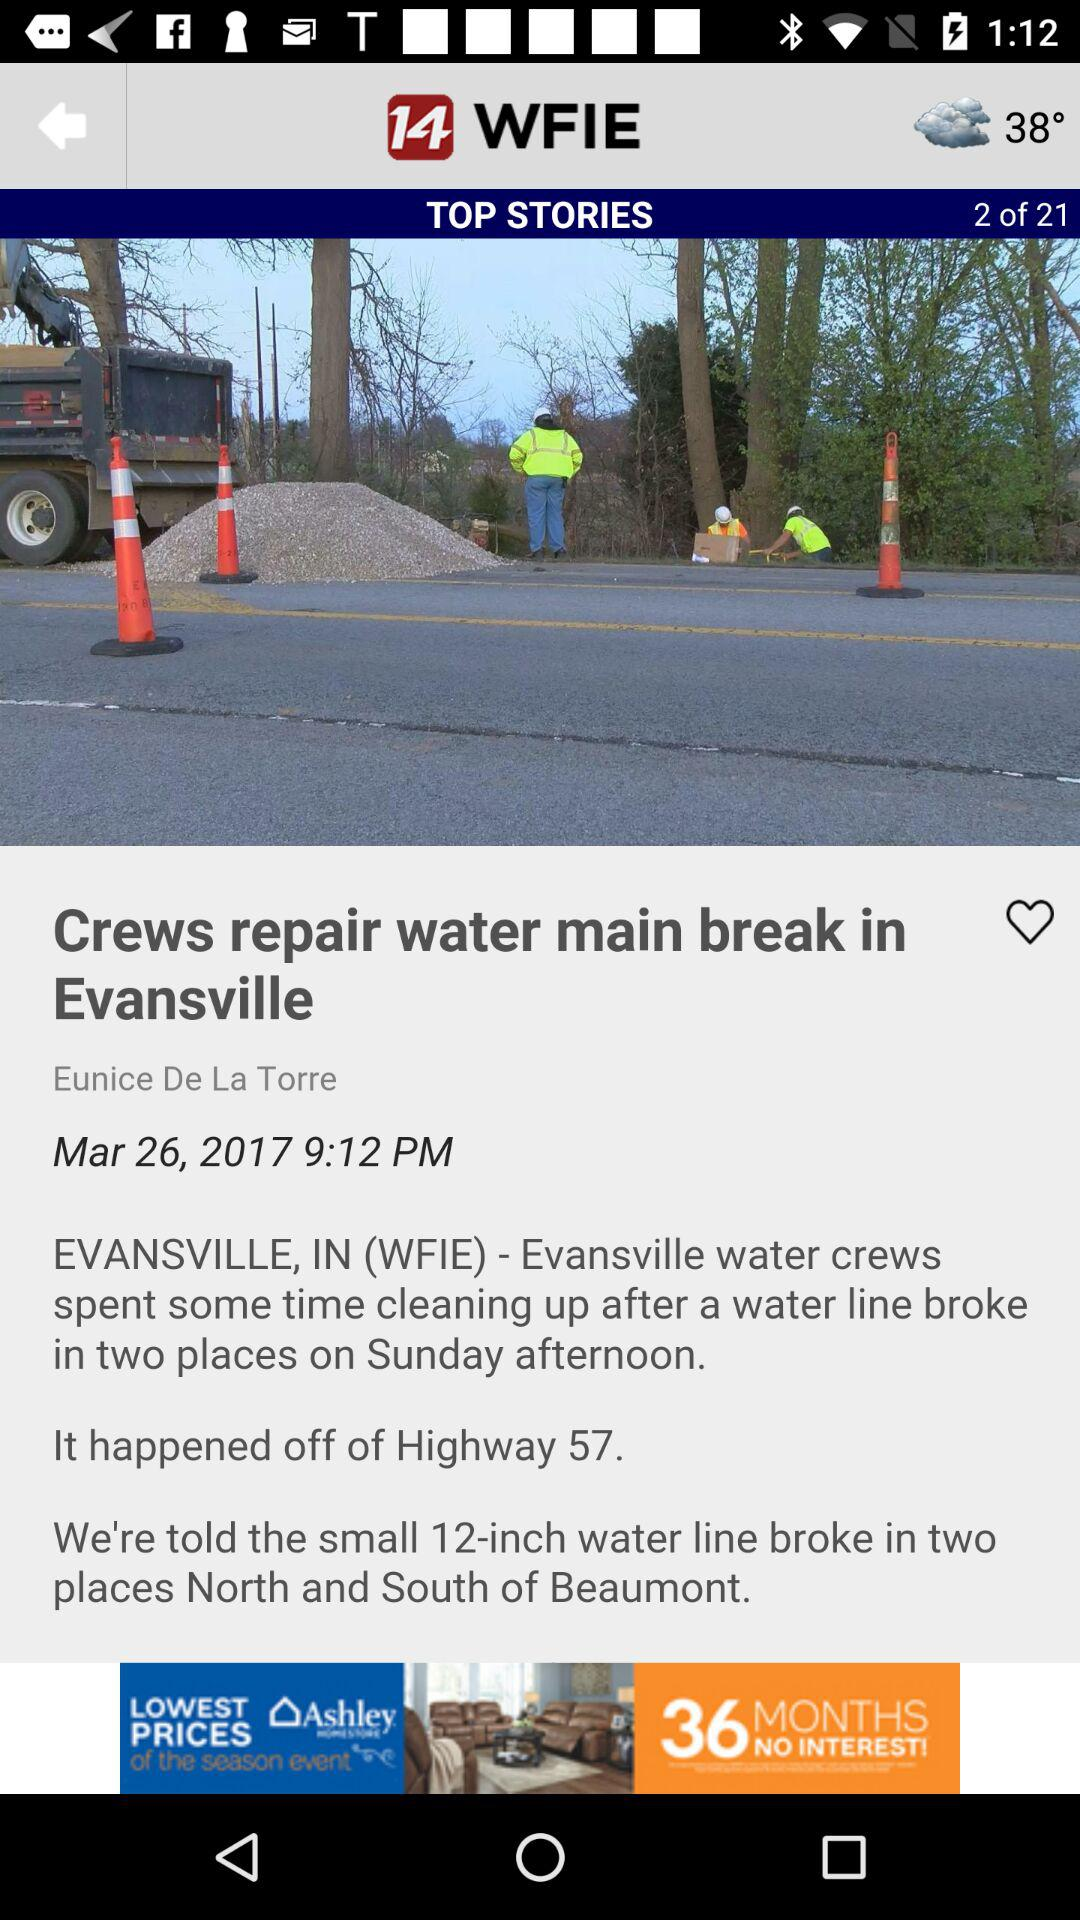What is the temperature? The temperature is 38°. 